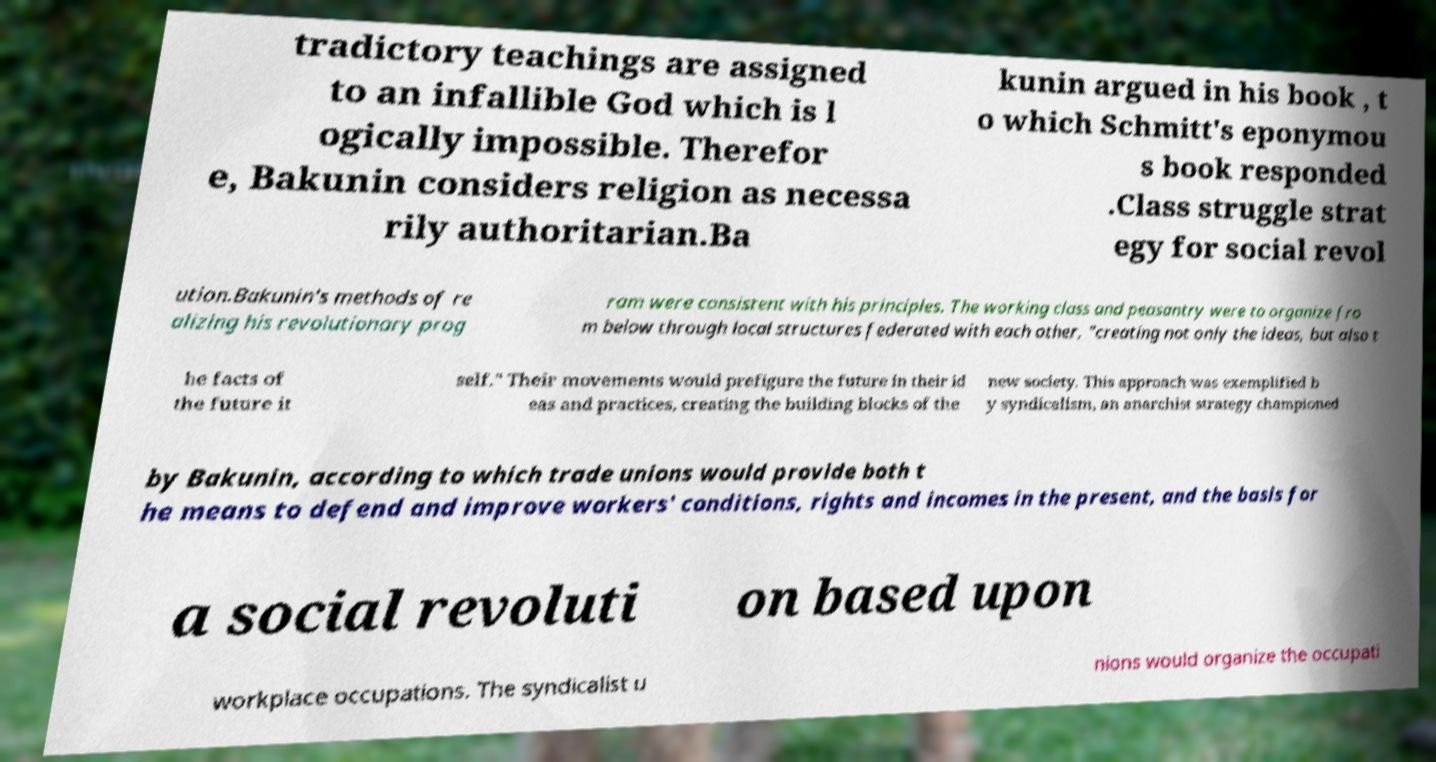Please read and relay the text visible in this image. What does it say? tradictory teachings are assigned to an infallible God which is l ogically impossible. Therefor e, Bakunin considers religion as necessa rily authoritarian.Ba kunin argued in his book , t o which Schmitt's eponymou s book responded .Class struggle strat egy for social revol ution.Bakunin's methods of re alizing his revolutionary prog ram were consistent with his principles. The working class and peasantry were to organize fro m below through local structures federated with each other, "creating not only the ideas, but also t he facts of the future it self." Their movements would prefigure the future in their id eas and practices, creating the building blocks of the new society. This approach was exemplified b y syndicalism, an anarchist strategy championed by Bakunin, according to which trade unions would provide both t he means to defend and improve workers' conditions, rights and incomes in the present, and the basis for a social revoluti on based upon workplace occupations. The syndicalist u nions would organize the occupati 